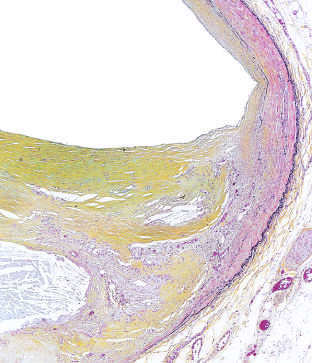s the media of the artery thinned under the most advanced plaque?
Answer the question using a single word or phrase. Yes 